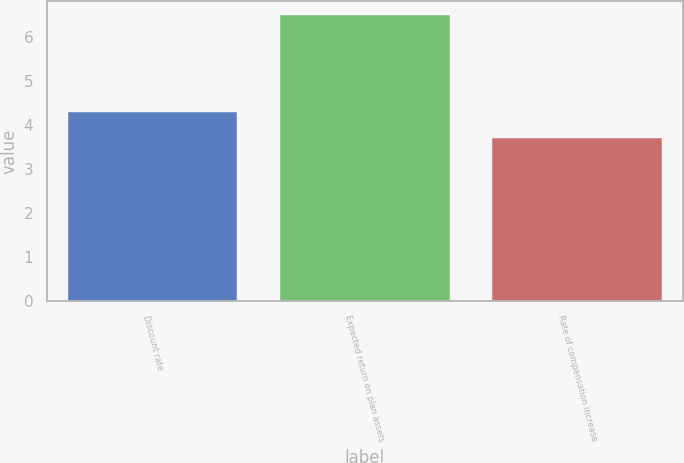Convert chart to OTSL. <chart><loc_0><loc_0><loc_500><loc_500><bar_chart><fcel>Discount rate<fcel>Expected return on plan assets<fcel>Rate of compensation increase<nl><fcel>4.3<fcel>6.5<fcel>3.7<nl></chart> 